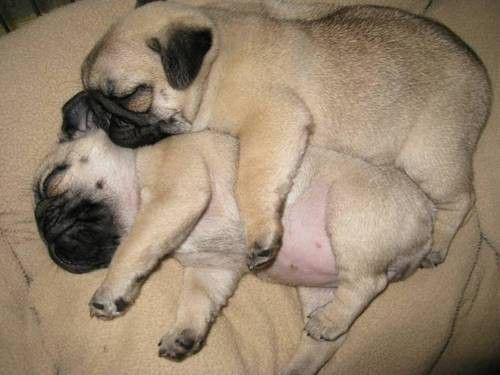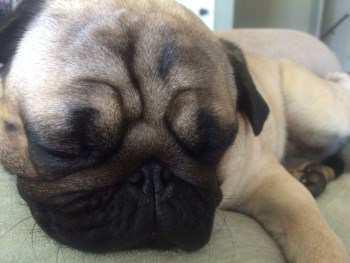The first image is the image on the left, the second image is the image on the right. For the images displayed, is the sentence "puppies are sleeping on their back with bellys exposed" factually correct? Answer yes or no. No. The first image is the image on the left, the second image is the image on the right. For the images shown, is this caption "At least one of the images shows a dog with a visible tongue outside of it's mouth." true? Answer yes or no. No. 